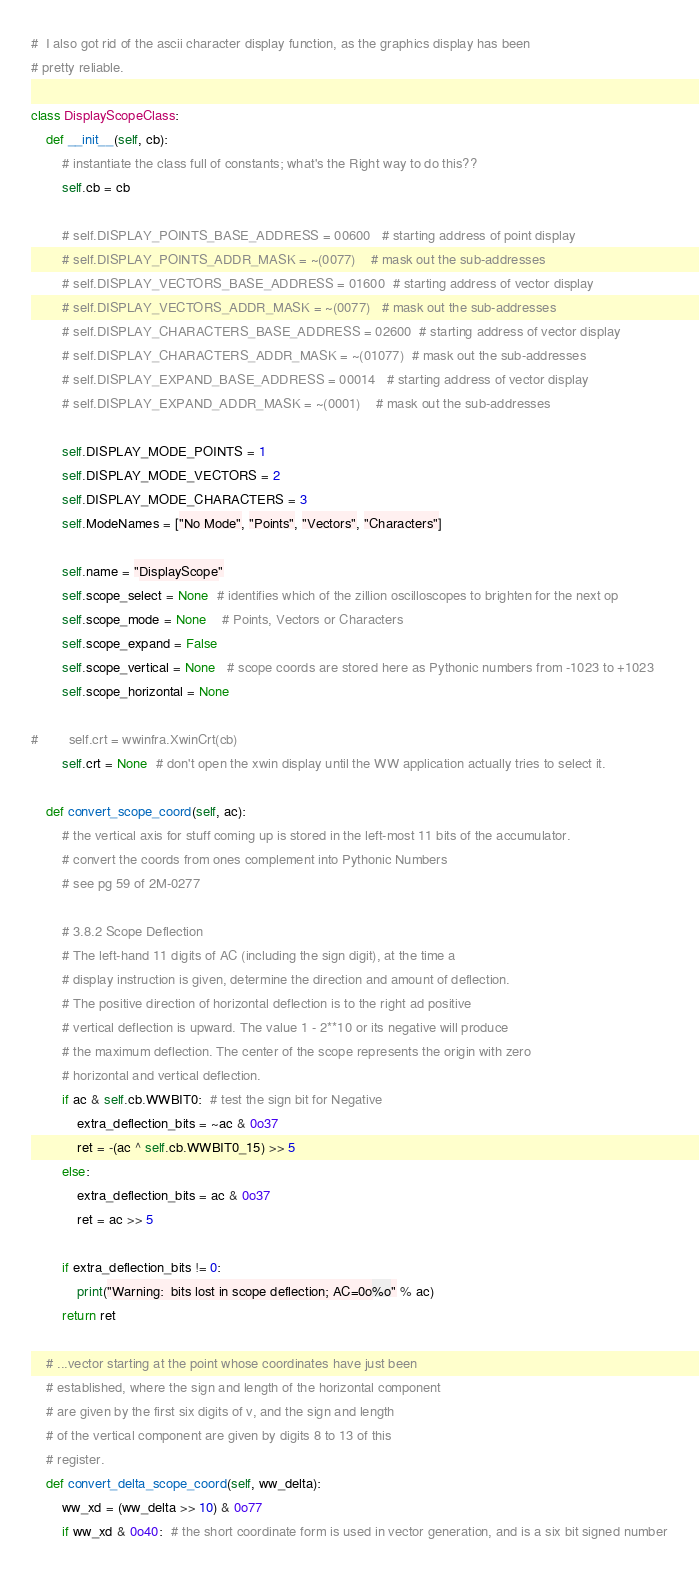Convert code to text. <code><loc_0><loc_0><loc_500><loc_500><_Python_>#  I also got rid of the ascii character display function, as the graphics display has been
# pretty reliable.

class DisplayScopeClass:
    def __init__(self, cb):
        # instantiate the class full of constants; what's the Right way to do this??
        self.cb = cb

        # self.DISPLAY_POINTS_BASE_ADDRESS = 00600   # starting address of point display
        # self.DISPLAY_POINTS_ADDR_MASK = ~(0077)    # mask out the sub-addresses
        # self.DISPLAY_VECTORS_BASE_ADDRESS = 01600  # starting address of vector display
        # self.DISPLAY_VECTORS_ADDR_MASK = ~(0077)   # mask out the sub-addresses
        # self.DISPLAY_CHARACTERS_BASE_ADDRESS = 02600  # starting address of vector display
        # self.DISPLAY_CHARACTERS_ADDR_MASK = ~(01077)  # mask out the sub-addresses
        # self.DISPLAY_EXPAND_BASE_ADDRESS = 00014   # starting address of vector display
        # self.DISPLAY_EXPAND_ADDR_MASK = ~(0001)    # mask out the sub-addresses

        self.DISPLAY_MODE_POINTS = 1
        self.DISPLAY_MODE_VECTORS = 2
        self.DISPLAY_MODE_CHARACTERS = 3
        self.ModeNames = ["No Mode", "Points", "Vectors", "Characters"]

        self.name = "DisplayScope"
        self.scope_select = None  # identifies which of the zillion oscilloscopes to brighten for the next op
        self.scope_mode = None    # Points, Vectors or Characters
        self.scope_expand = False
        self.scope_vertical = None   # scope coords are stored here as Pythonic numbers from -1023 to +1023
        self.scope_horizontal = None

#        self.crt = wwinfra.XwinCrt(cb)
        self.crt = None  # don't open the xwin display until the WW application actually tries to select it.

    def convert_scope_coord(self, ac):
        # the vertical axis for stuff coming up is stored in the left-most 11 bits of the accumulator.
        # convert the coords from ones complement into Pythonic Numbers
        # see pg 59 of 2M-0277

        # 3.8.2 Scope Deflection
        # The left-hand 11 digits of AC (including the sign digit), at the time a
        # display instruction is given, determine the direction and amount of deflection.
        # The positive direction of horizontal deflection is to the right ad positive
        # vertical deflection is upward. The value 1 - 2**10 or its negative will produce
        # the maximum deflection. The center of the scope represents the origin with zero
        # horizontal and vertical deflection.
        if ac & self.cb.WWBIT0:  # test the sign bit for Negative
            extra_deflection_bits = ~ac & 0o37
            ret = -(ac ^ self.cb.WWBIT0_15) >> 5
        else:
            extra_deflection_bits = ac & 0o37
            ret = ac >> 5

        if extra_deflection_bits != 0:
            print("Warning:  bits lost in scope deflection; AC=0o%o" % ac)
        return ret

    # ...vector starting at the point whose coordinates have just been
    # established, where the sign and length of the horizontal component
    # are given by the first six digits of v, and the sign and length
    # of the vertical component are given by digits 8 to 13 of this
    # register.
    def convert_delta_scope_coord(self, ww_delta):
        ww_xd = (ww_delta >> 10) & 0o77
        if ww_xd & 0o40:  # the short coordinate form is used in vector generation, and is a six bit signed number</code> 